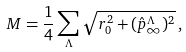<formula> <loc_0><loc_0><loc_500><loc_500>M = \frac { 1 } { 4 } \sum _ { \Lambda } \sqrt { r _ { 0 } ^ { 2 } + ( \hat { p } ^ { \Lambda } _ { \infty } ) ^ { 2 } } \, ,</formula> 